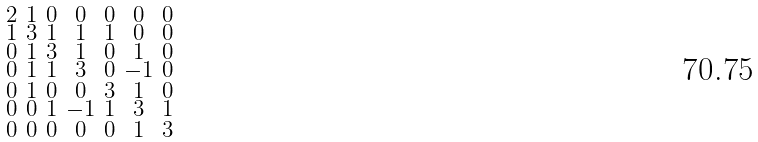<formula> <loc_0><loc_0><loc_500><loc_500>\begin{smallmatrix} 2 & 1 & 0 & 0 & 0 & 0 & 0 \\ 1 & 3 & 1 & 1 & 1 & 0 & 0 \\ 0 & 1 & 3 & 1 & 0 & 1 & 0 \\ 0 & 1 & 1 & 3 & 0 & - 1 & 0 \\ 0 & 1 & 0 & 0 & 3 & 1 & 0 \\ 0 & 0 & 1 & - 1 & 1 & 3 & 1 \\ 0 & 0 & 0 & 0 & 0 & 1 & 3 \end{smallmatrix}</formula> 